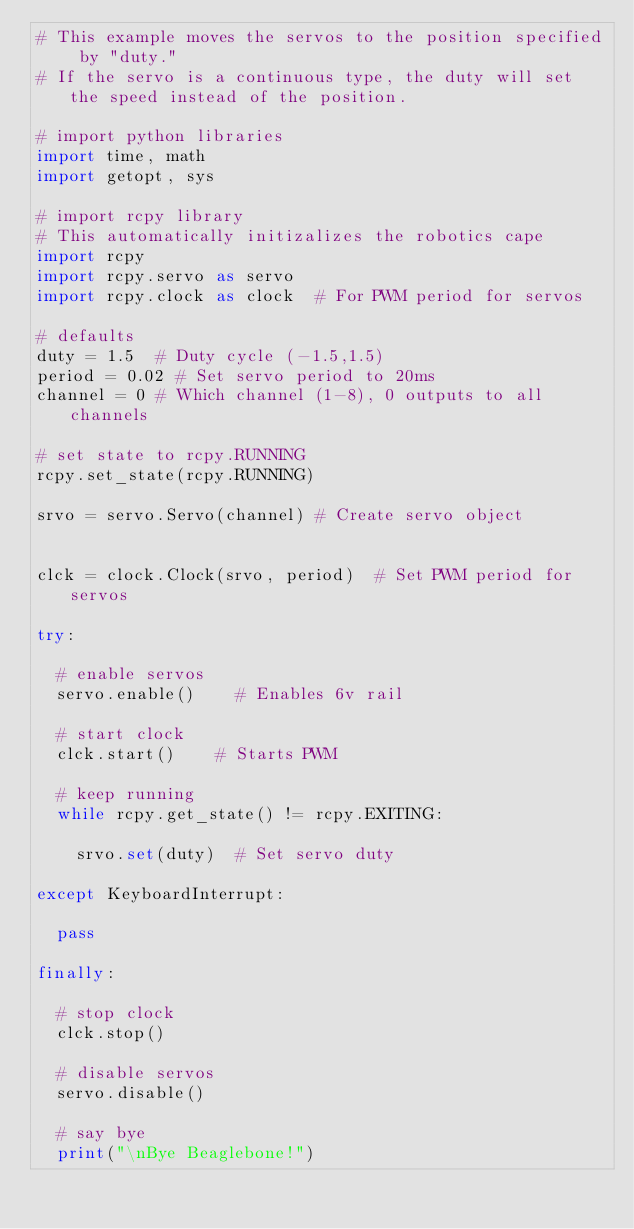Convert code to text. <code><loc_0><loc_0><loc_500><loc_500><_Python_># This example moves the servos to the position specified by "duty."   
# If the servo is a continuous type, the duty will set the speed instead of the position. 

# import python libraries
import time, math
import getopt, sys

# import rcpy library
# This automatically initizalizes the robotics cape
import rcpy 
import rcpy.servo as servo
import rcpy.clock as clock	# For PWM period for servos

# defaults
duty = 1.5	# Duty cycle (-1.5,1.5)
period = 0.02	# Set servo period to 20ms
channel = 0	# Which channel (1-8), 0 outputs to all channels

# set state to rcpy.RUNNING
rcpy.set_state(rcpy.RUNNING)

srvo = servo.Servo(channel)	# Create servo object


clck = clock.Clock(srvo, period)	# Set PWM period for servos

try:

	# enable servos
	servo.enable()		# Enables 6v rail

	# start clock
	clck.start()		# Starts PWM

	# keep running
	while rcpy.get_state() != rcpy.EXITING:

		srvo.set(duty)	# Set servo duty

except KeyboardInterrupt:
	
	pass

finally:

	# stop clock
	clck.stop()

	# disable servos
	servo.disable()

	# say bye
	print("\nBye Beaglebone!")

</code> 